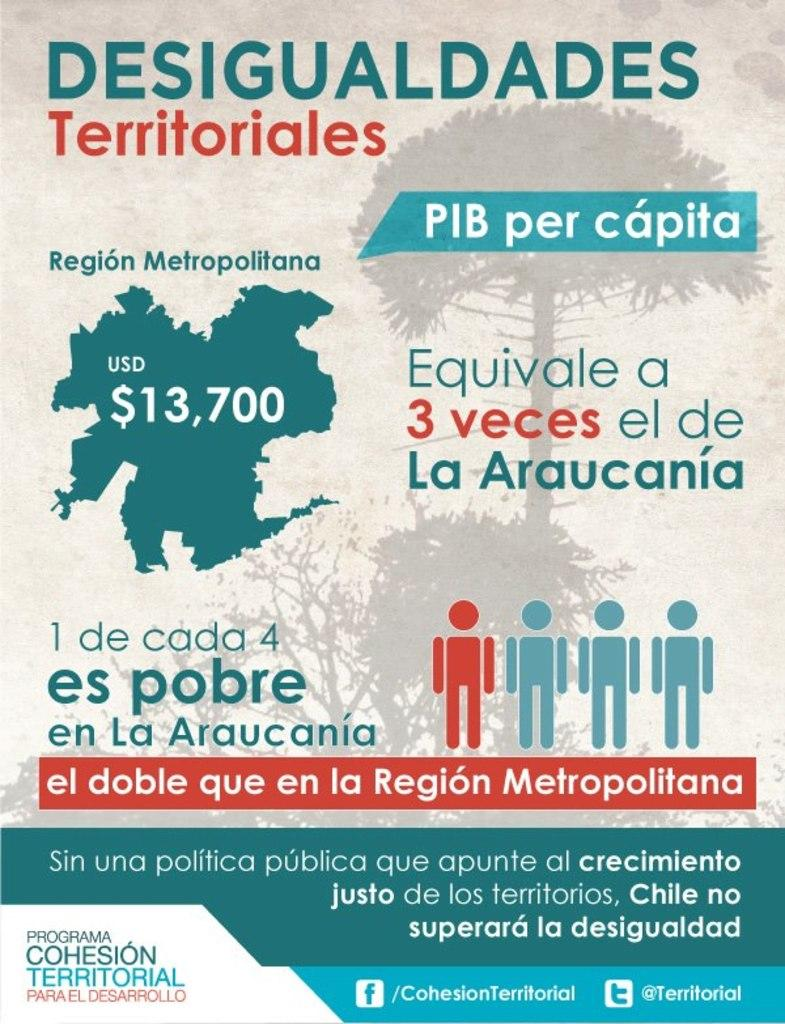What type of publication is visible in the image? There is a magazine in the image. What can be found within the magazine? The magazine contains text, images, numerical numbers, and figures. How many feathers are used to decorate the edges of the magazine in the image? There are no feathers present in the image; the magazine contains text, images, numerical numbers, and figures. 